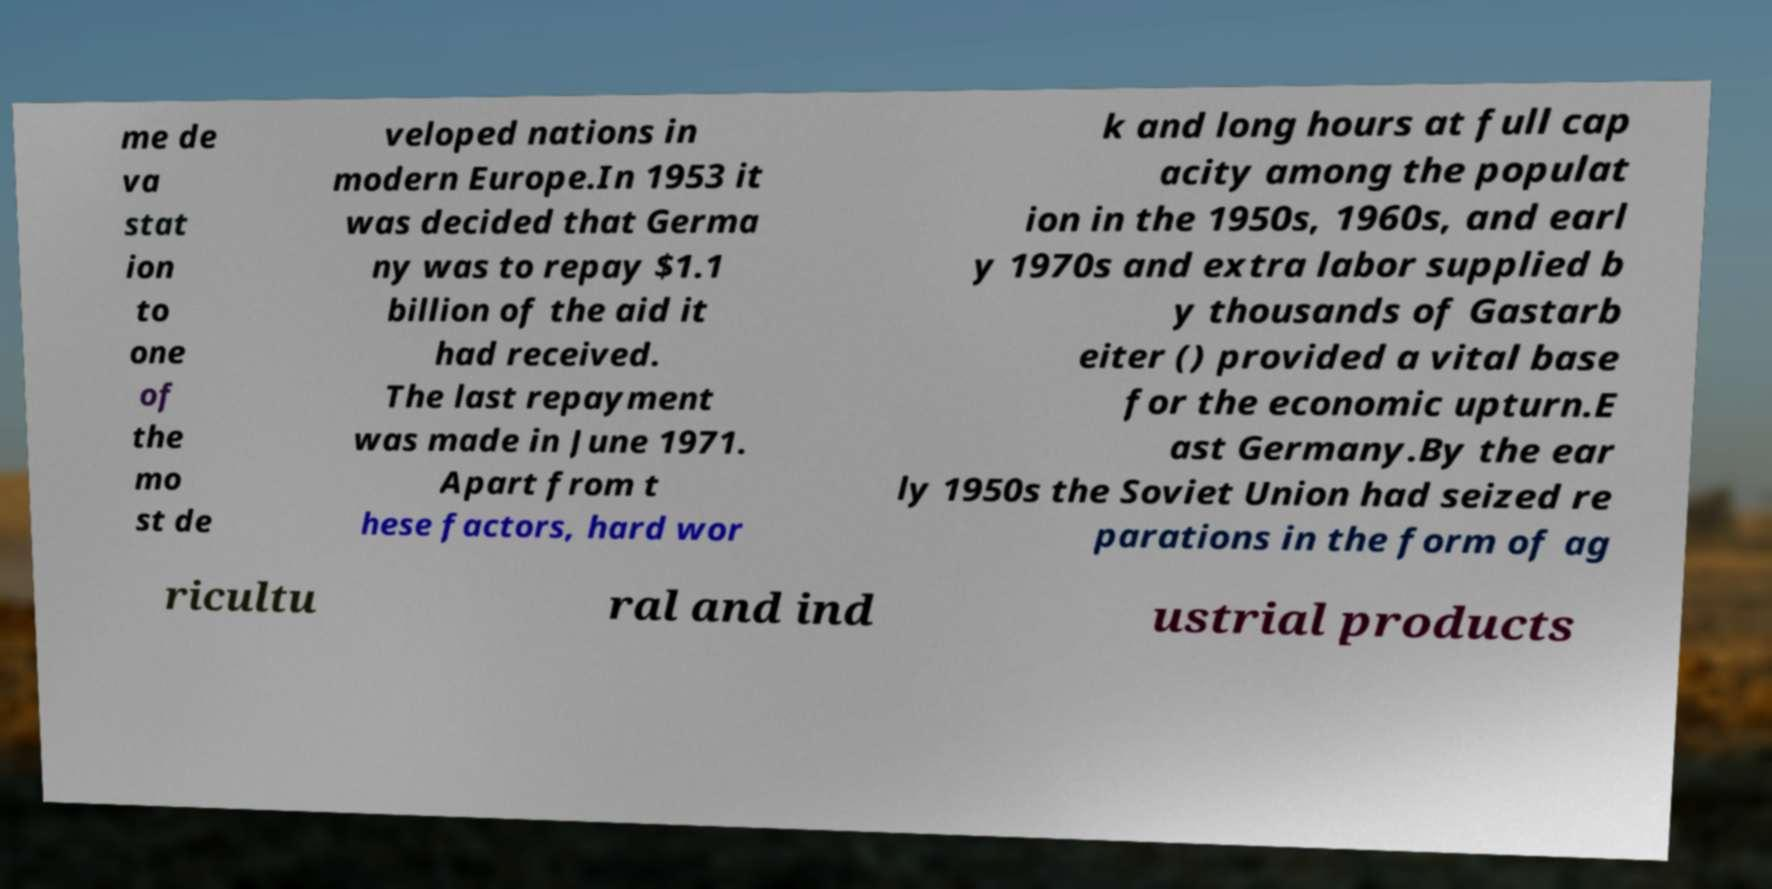Please identify and transcribe the text found in this image. me de va stat ion to one of the mo st de veloped nations in modern Europe.In 1953 it was decided that Germa ny was to repay $1.1 billion of the aid it had received. The last repayment was made in June 1971. Apart from t hese factors, hard wor k and long hours at full cap acity among the populat ion in the 1950s, 1960s, and earl y 1970s and extra labor supplied b y thousands of Gastarb eiter () provided a vital base for the economic upturn.E ast Germany.By the ear ly 1950s the Soviet Union had seized re parations in the form of ag ricultu ral and ind ustrial products 